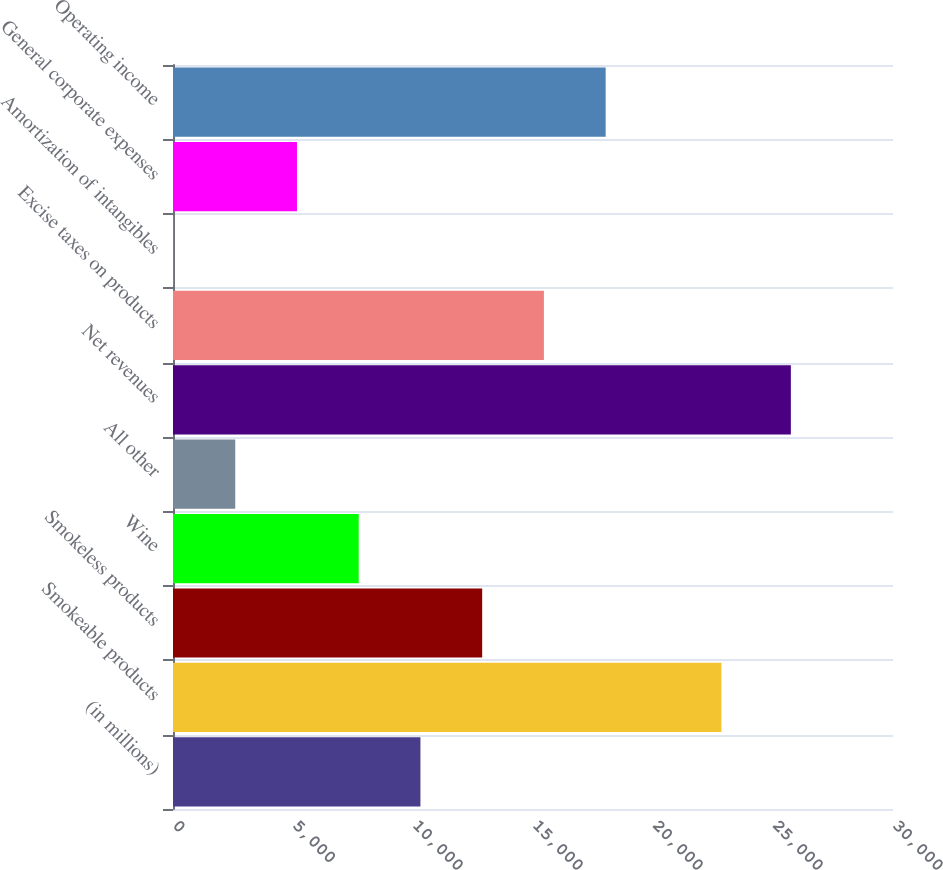<chart> <loc_0><loc_0><loc_500><loc_500><bar_chart><fcel>(in millions)<fcel>Smokeable products<fcel>Smokeless products<fcel>Wine<fcel>All other<fcel>Net revenues<fcel>Excise taxes on products<fcel>Amortization of intangibles<fcel>General corporate expenses<fcel>Operating income<nl><fcel>10310.2<fcel>22851<fcel>12882.5<fcel>7737.9<fcel>2593.3<fcel>25744<fcel>15454.8<fcel>21<fcel>5165.6<fcel>18027.1<nl></chart> 